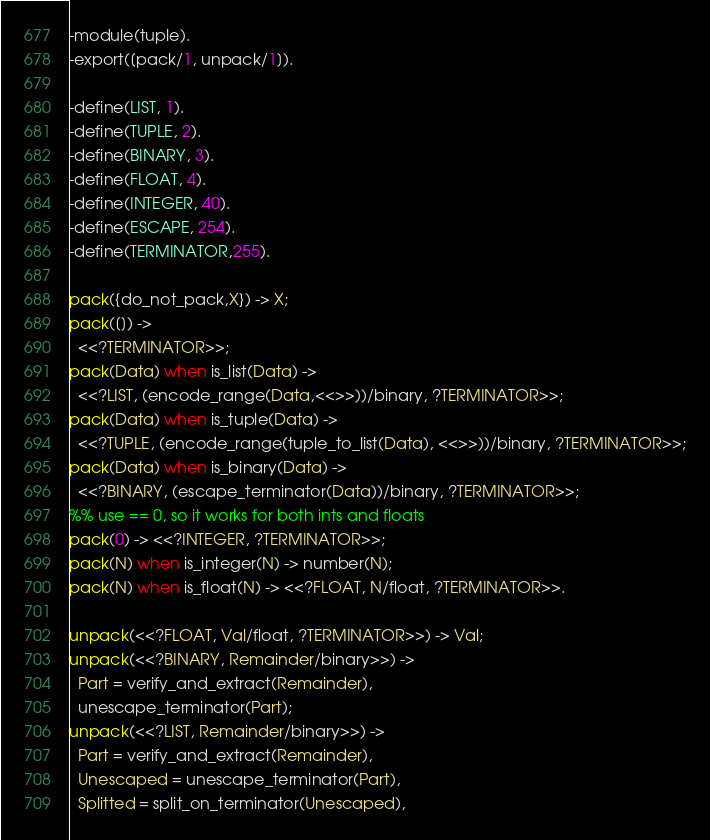<code> <loc_0><loc_0><loc_500><loc_500><_Erlang_>-module(tuple).
-export([pack/1, unpack/1]).

-define(LIST, 1).
-define(TUPLE, 2).
-define(BINARY, 3).
-define(FLOAT, 4).
-define(INTEGER, 40).
-define(ESCAPE, 254).
-define(TERMINATOR,255).

pack({do_not_pack,X}) -> X;
pack([]) ->
  <<?TERMINATOR>>; 
pack(Data) when is_list(Data) ->
  <<?LIST, (encode_range(Data,<<>>))/binary, ?TERMINATOR>>;
pack(Data) when is_tuple(Data) ->
  <<?TUPLE, (encode_range(tuple_to_list(Data), <<>>))/binary, ?TERMINATOR>>;
pack(Data) when is_binary(Data) ->
  <<?BINARY, (escape_terminator(Data))/binary, ?TERMINATOR>>;
%% use == 0, so it works for both ints and floats
pack(0) -> <<?INTEGER, ?TERMINATOR>>;
pack(N) when is_integer(N) -> number(N);
pack(N) when is_float(N) -> <<?FLOAT, N/float, ?TERMINATOR>>.

unpack(<<?FLOAT, Val/float, ?TERMINATOR>>) -> Val;
unpack(<<?BINARY, Remainder/binary>>) ->
  Part = verify_and_extract(Remainder),
  unescape_terminator(Part);
unpack(<<?LIST, Remainder/binary>>) ->
  Part = verify_and_extract(Remainder),
  Unescaped = unescape_terminator(Part),
  Splitted = split_on_terminator(Unescaped),</code> 